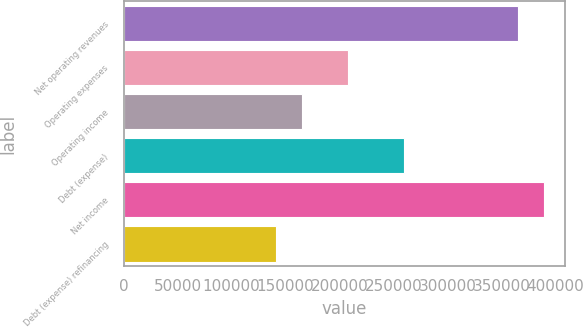<chart> <loc_0><loc_0><loc_500><loc_500><bar_chart><fcel>Net operating revenues<fcel>Operating expenses<fcel>Operating income<fcel>Debt (expense)<fcel>Net income<fcel>Debt (expense) refinancing<nl><fcel>365728<fcel>208042<fcel>165516<fcel>259745<fcel>389757<fcel>141487<nl></chart> 